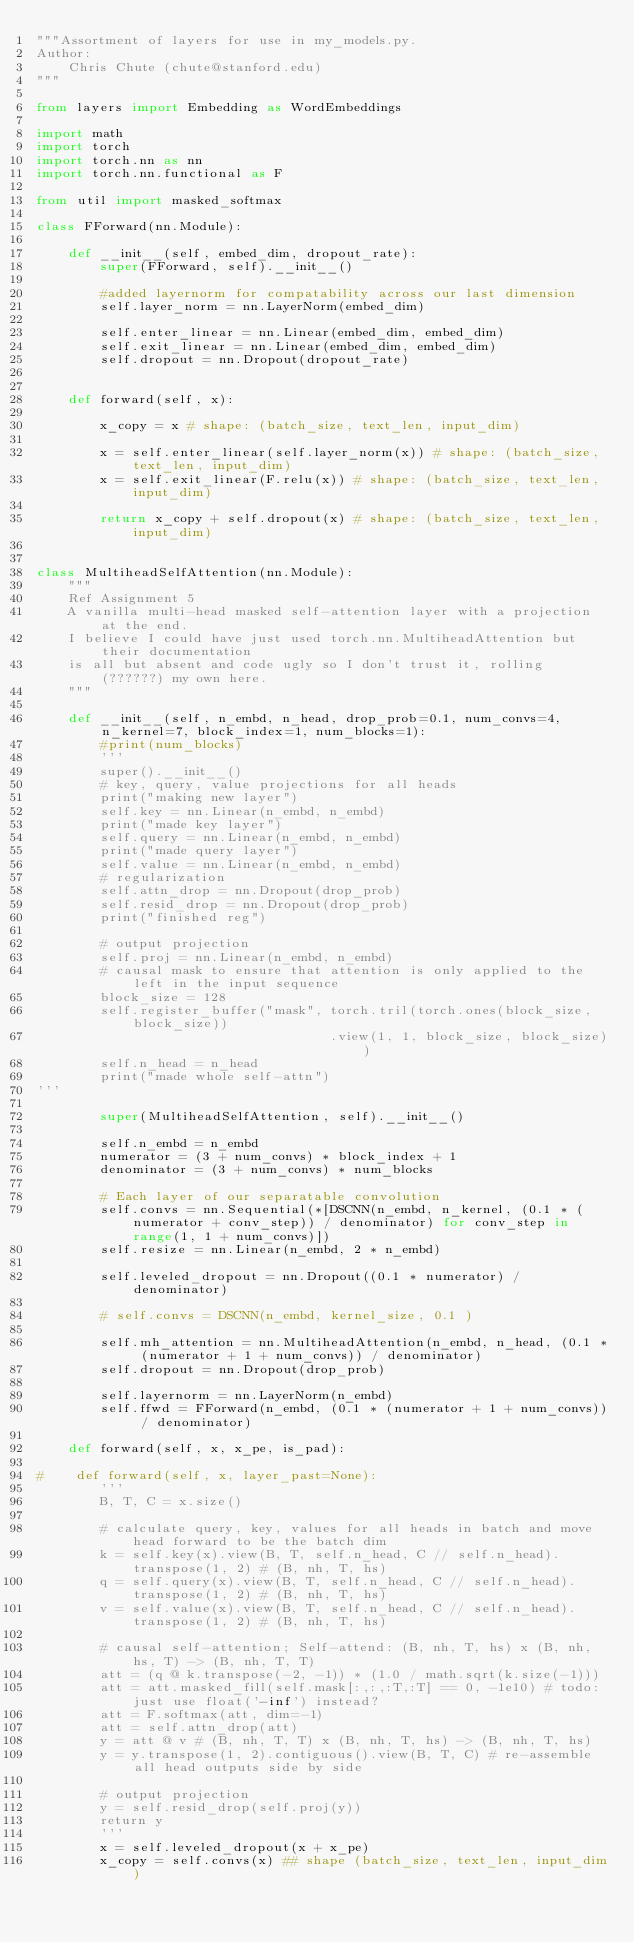<code> <loc_0><loc_0><loc_500><loc_500><_Python_>"""Assortment of layers for use in my_models.py.
Author:
    Chris Chute (chute@stanford.edu)
"""

from layers import Embedding as WordEmbeddings

import math
import torch
import torch.nn as nn
import torch.nn.functional as F

from util import masked_softmax

class FForward(nn.Module):

    def __init__(self, embed_dim, dropout_rate):
        super(FForward, self).__init__()
        
        #added layernorm for compatability across our last dimension  
        self.layer_norm = nn.LayerNorm(embed_dim)

        self.enter_linear = nn.Linear(embed_dim, embed_dim)
        self.exit_linear = nn.Linear(embed_dim, embed_dim)
        self.dropout = nn.Dropout(dropout_rate)
        
        
    def forward(self, x):

        x_copy = x # shape: (batch_size, text_len, input_dim)
        
        x = self.enter_linear(self.layer_norm(x)) # shape: (batch_size, text_len, input_dim)
        x = self.exit_linear(F.relu(x)) # shape: (batch_size, text_len, input_dim)
        
        return x_copy + self.dropout(x) # shape: (batch_size, text_len, input_dim)


class MultiheadSelfAttention(nn.Module):
    """
    Ref Assignment 5
    A vanilla multi-head masked self-attention layer with a projection at the end.
    I believe I could have just used torch.nn.MultiheadAttention but their documentation
    is all but absent and code ugly so I don't trust it, rolling (??????) my own here.
    """

    def __init__(self, n_embd, n_head, drop_prob=0.1, num_convs=4, n_kernel=7, block_index=1, num_blocks=1):
        #print(num_blocks)
        '''
        super().__init__()
        # key, query, value projections for all heads
        print("making new layer")
        self.key = nn.Linear(n_embd, n_embd)
        print("made key layer")
        self.query = nn.Linear(n_embd, n_embd)
        print("made query layer")
        self.value = nn.Linear(n_embd, n_embd)
        # regularization
        self.attn_drop = nn.Dropout(drop_prob)
        self.resid_drop = nn.Dropout(drop_prob)
        print("finished reg")

        # output projection
        self.proj = nn.Linear(n_embd, n_embd)
        # causal mask to ensure that attention is only applied to the left in the input sequence
        block_size = 128
        self.register_buffer("mask", torch.tril(torch.ones(block_size, block_size))
                                     .view(1, 1, block_size, block_size))
        self.n_head = n_head
        print("made whole self-attn")
'''

        super(MultiheadSelfAttention, self).__init__()

        self.n_embd = n_embd
        numerator = (3 + num_convs) * block_index + 1
        denominator = (3 + num_convs) * num_blocks

        # Each layer of our separatable convolution
        self.convs = nn.Sequential(*[DSCNN(n_embd, n_kernel, (0.1 * (numerator + conv_step)) / denominator) for conv_step in range(1, 1 + num_convs)])
        self.resize = nn.Linear(n_embd, 2 * n_embd)

        self.leveled_dropout = nn.Dropout((0.1 * numerator) / denominator)
        
        # self.convs = DSCNN(n_embd, kernel_size, 0.1 )
                         
        self.mh_attention = nn.MultiheadAttention(n_embd, n_head, (0.1 * (numerator + 1 + num_convs)) / denominator)
        self.dropout = nn.Dropout(drop_prob)

        self.layernorm = nn.LayerNorm(n_embd)
        self.ffwd = FForward(n_embd, (0.1 * (numerator + 1 + num_convs)) / denominator)

    def forward(self, x, x_pe, is_pad):

#    def forward(self, x, layer_past=None):
        '''
        B, T, C = x.size()

        # calculate query, key, values for all heads in batch and move head forward to be the batch dim
        k = self.key(x).view(B, T, self.n_head, C // self.n_head).transpose(1, 2) # (B, nh, T, hs)
        q = self.query(x).view(B, T, self.n_head, C // self.n_head).transpose(1, 2) # (B, nh, T, hs)
        v = self.value(x).view(B, T, self.n_head, C // self.n_head).transpose(1, 2) # (B, nh, T, hs)

        # causal self-attention; Self-attend: (B, nh, T, hs) x (B, nh, hs, T) -> (B, nh, T, T)
        att = (q @ k.transpose(-2, -1)) * (1.0 / math.sqrt(k.size(-1)))
        att = att.masked_fill(self.mask[:,:,:T,:T] == 0, -1e10) # todo: just use float('-inf') instead?
        att = F.softmax(att, dim=-1)
        att = self.attn_drop(att)
        y = att @ v # (B, nh, T, T) x (B, nh, T, hs) -> (B, nh, T, hs)
        y = y.transpose(1, 2).contiguous().view(B, T, C) # re-assemble all head outputs side by side

        # output projection
        y = self.resid_drop(self.proj(y))
        return y
        '''
        x = self.leveled_dropout(x + x_pe)
        x_copy = self.convs(x) ## shape (batch_size, text_len, input_dim)</code> 